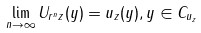Convert formula to latex. <formula><loc_0><loc_0><loc_500><loc_500>\lim _ { n \to \infty } U _ { r ^ { n } z } ( y ) = u _ { z } ( y ) , y \in C _ { u _ { z } }</formula> 